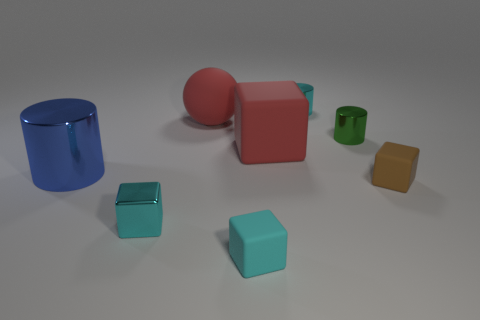How many blocks are either tiny brown objects or tiny rubber things?
Your answer should be very brief. 2. There is a cylinder that is on the left side of the cyan metal object that is right of the small thing that is in front of the metallic block; what size is it?
Offer a very short reply. Large. There is a metallic object that is behind the brown rubber cube and left of the rubber sphere; what is its color?
Give a very brief answer. Blue. There is a blue metal cylinder; does it have the same size as the cyan object that is behind the large blue cylinder?
Your answer should be very brief. No. Are there any other things that have the same shape as the tiny cyan matte thing?
Provide a succinct answer. Yes. There is another large thing that is the same shape as the green metallic object; what is its color?
Your answer should be very brief. Blue. Is the size of the brown rubber object the same as the red ball?
Offer a terse response. No. What number of other things are the same size as the cyan metal cylinder?
Give a very brief answer. 4. What number of things are tiny cyan things that are behind the big red rubber block or things behind the brown thing?
Offer a very short reply. 5. There is a green thing that is the same size as the cyan metallic cube; what is its shape?
Your answer should be very brief. Cylinder. 